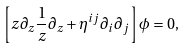<formula> <loc_0><loc_0><loc_500><loc_500>\left [ z \partial _ { z } \frac { 1 } { z } \partial _ { z } + \eta ^ { i j } \partial _ { i } \partial _ { j } \right ] \phi = 0 ,</formula> 